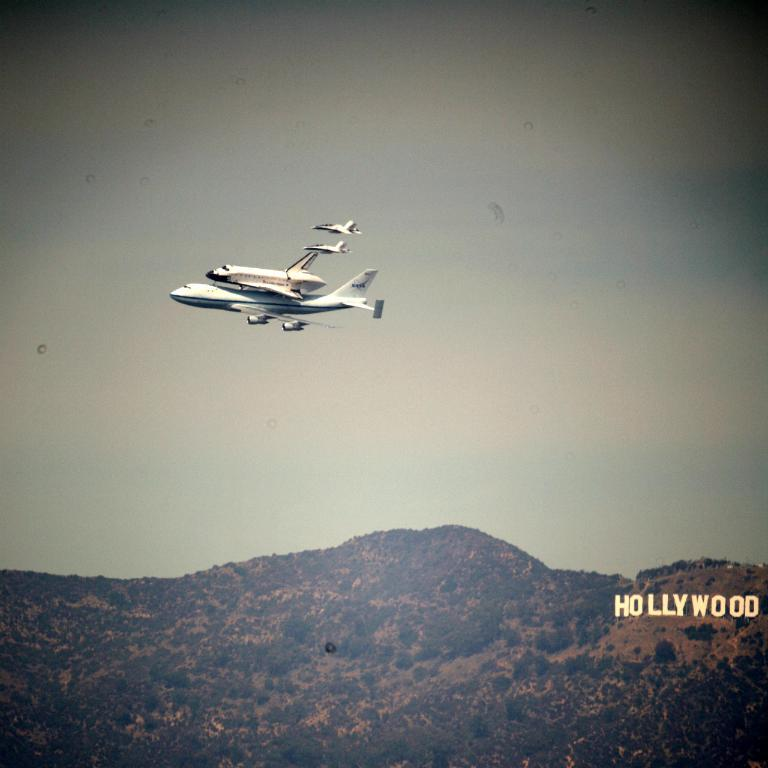<image>
Present a compact description of the photo's key features. Planes flying in the air above the Hollywood sign 